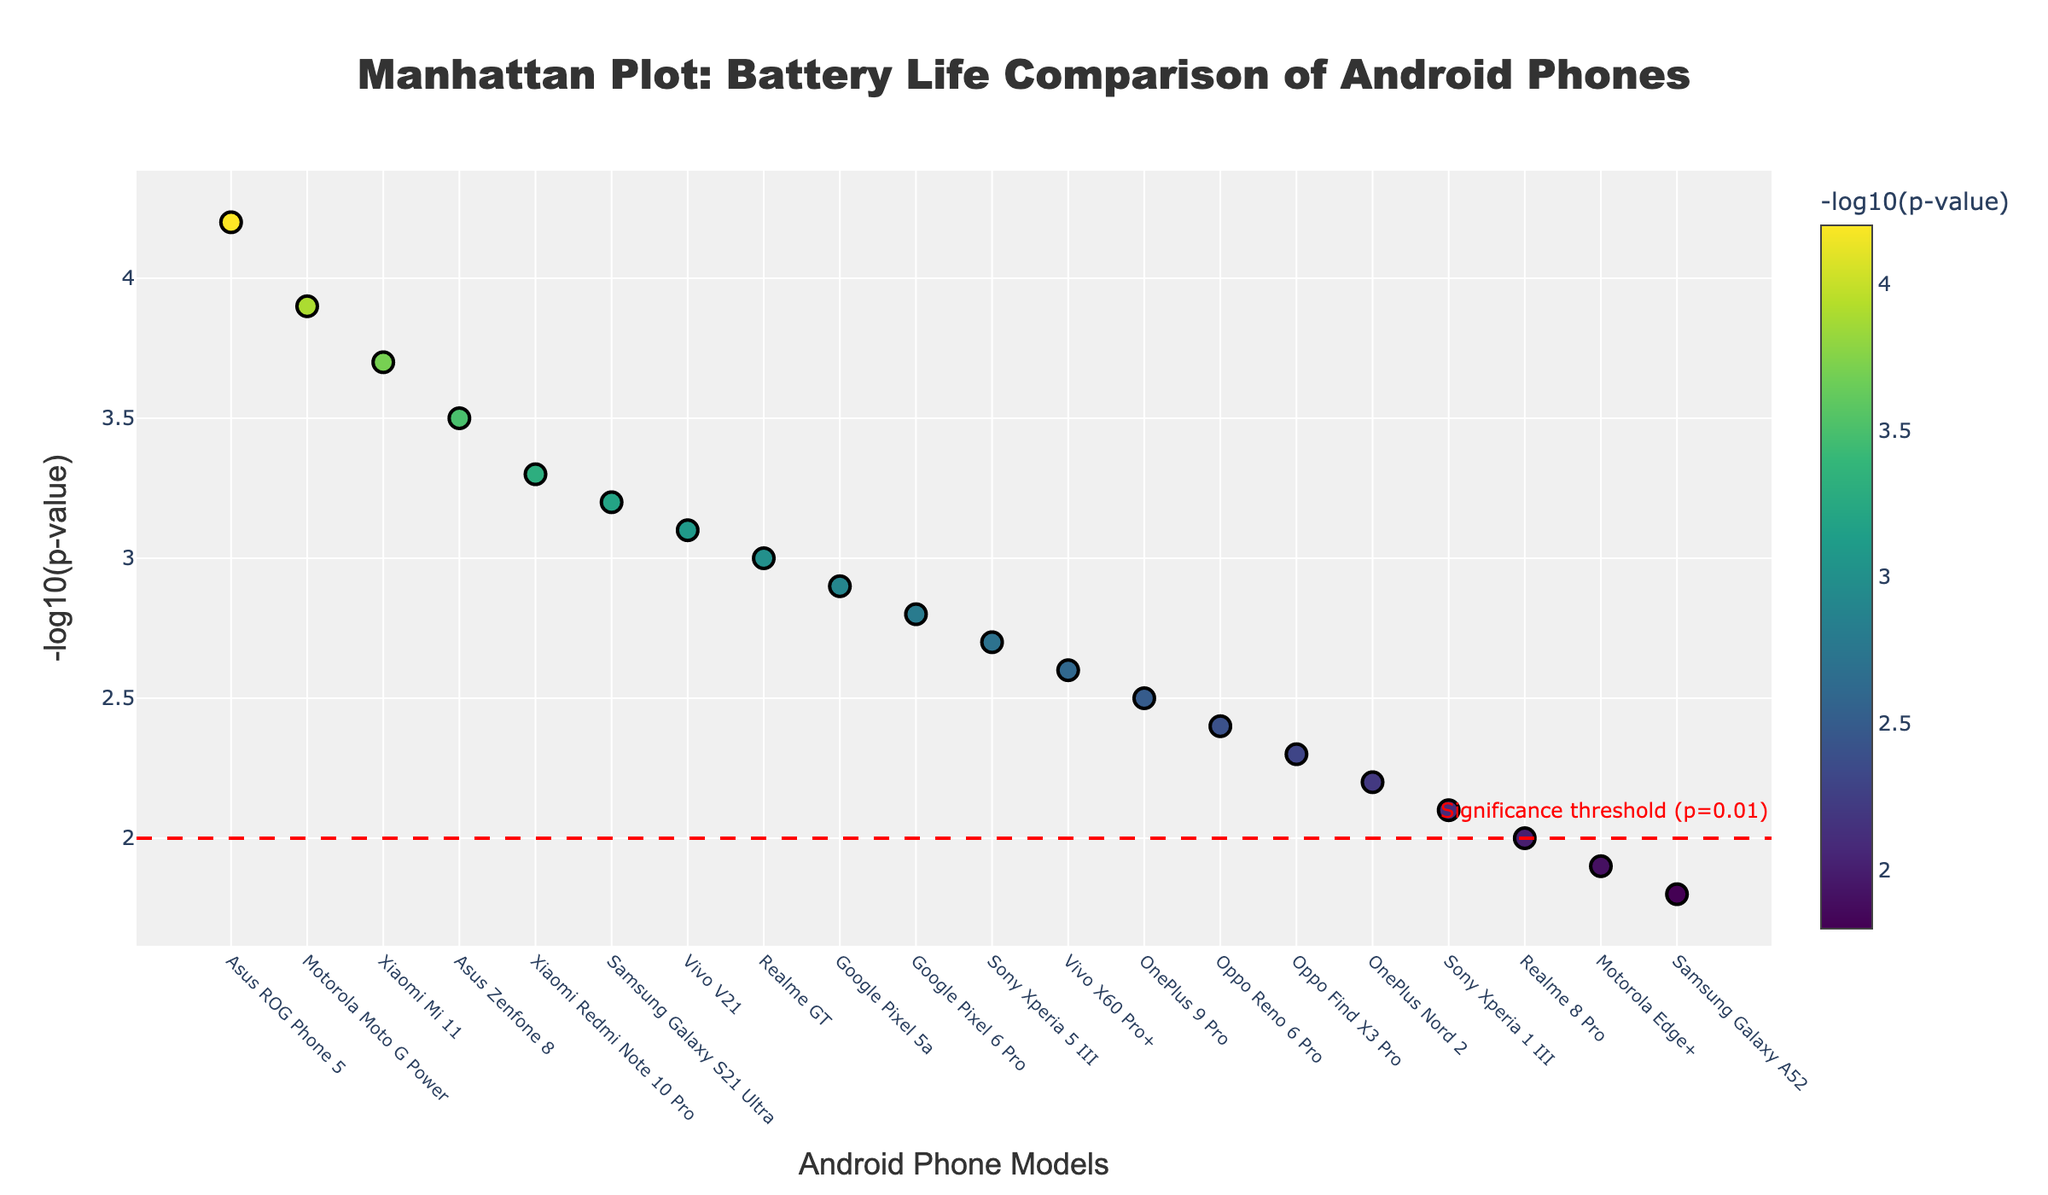What is the title of the plot? The title of the plot is displayed prominently at the top of the figure with large and bold font. The title reads "Manhattan Plot: Battery Life Comparison of Android Phones".
Answer: Manhattan Plot: Battery Life Comparison of Android Phones Which phone model has the highest -log10(p-value) in this plot? The markers' heights indicate the -log10(p-value) values. The highest marker on the y-axis corresponds to the Asus ROG Phone 5.
Answer: Asus ROG Phone 5 What does the red horizontal line at y=2 represent? There is a red horizontal line with a dash pattern drawn at y=2. An annotation beside the line states "Significance threshold (p=0.01)".
Answer: Significance threshold (p=0.01) Which usage scenario is associated with the Xiaomi Mi 11? The hover label and color of the marker representing Xiaomi Mi 11 indicate that it is associated with the Social Media usage scenario.
Answer: Social Media How many phone models have a -log10(p-value) greater than 3? We observe the markers and count those that have y-values greater than 3. There are six such phone models: Motorola Moto G Power, Asus ROG Phone 5, Xiaomi Mi 11, Samsung Galaxy S21 Ultra, Xiaomi Redmi Note 10 Pro, and Asus Zenfone 8.
Answer: 6 Which phone model has the lowest -log10(p-value) and what is its associated usage scenario? The lowest marker on the y-axis corresponds to the Samsung Galaxy A52 with a -log10(p-value) of 1.8. The hover text shows it is associated with the Email usage scenario.
Answer: Samsung Galaxy A52, Email Compare the -log10(p-value) of Asus ROG Phone 5 and Google Pixel 6 Pro. Which one is higher, and by how much? Asus ROG Phone 5 has a -log10(p-value) of 4.2 while Google Pixel 6 Pro has 2.8. The difference is calculated as 4.2 - 2.8 = 1.4.
Answer: Asus ROG Phone 5, 1.4 What are the axis titles in this plot? The x-axis title is "Android Phone Models" and the y-axis title is "-log10(p-value)". Both titles are prominently labeled on their respective axes.
Answer: Android Phone Models, -log10(p-value) 